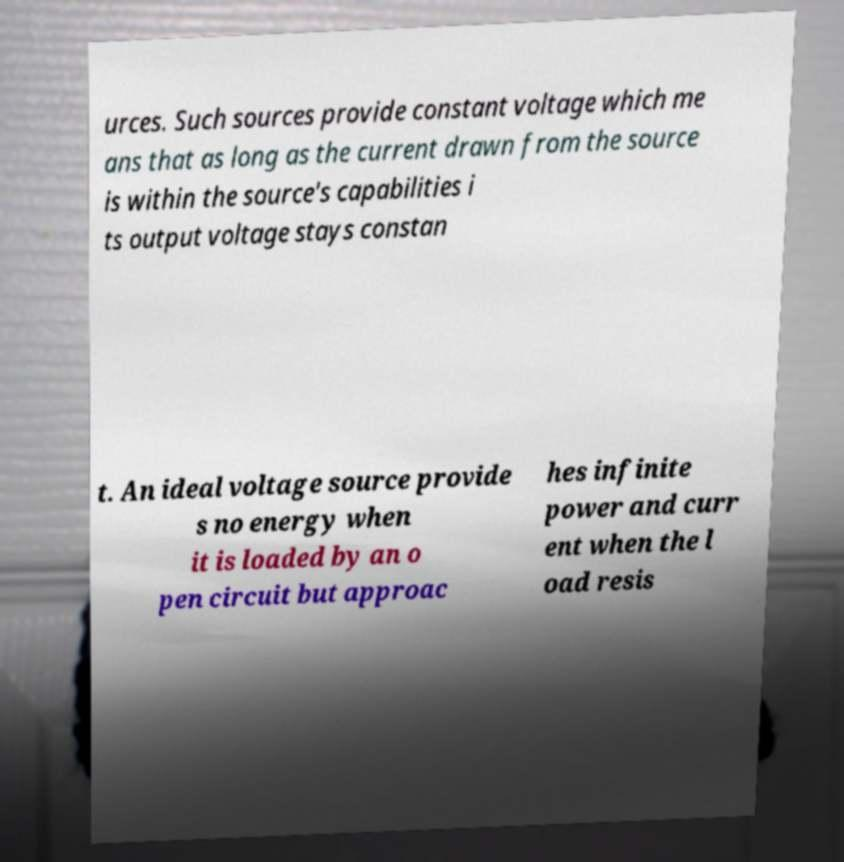Could you assist in decoding the text presented in this image and type it out clearly? urces. Such sources provide constant voltage which me ans that as long as the current drawn from the source is within the source's capabilities i ts output voltage stays constan t. An ideal voltage source provide s no energy when it is loaded by an o pen circuit but approac hes infinite power and curr ent when the l oad resis 